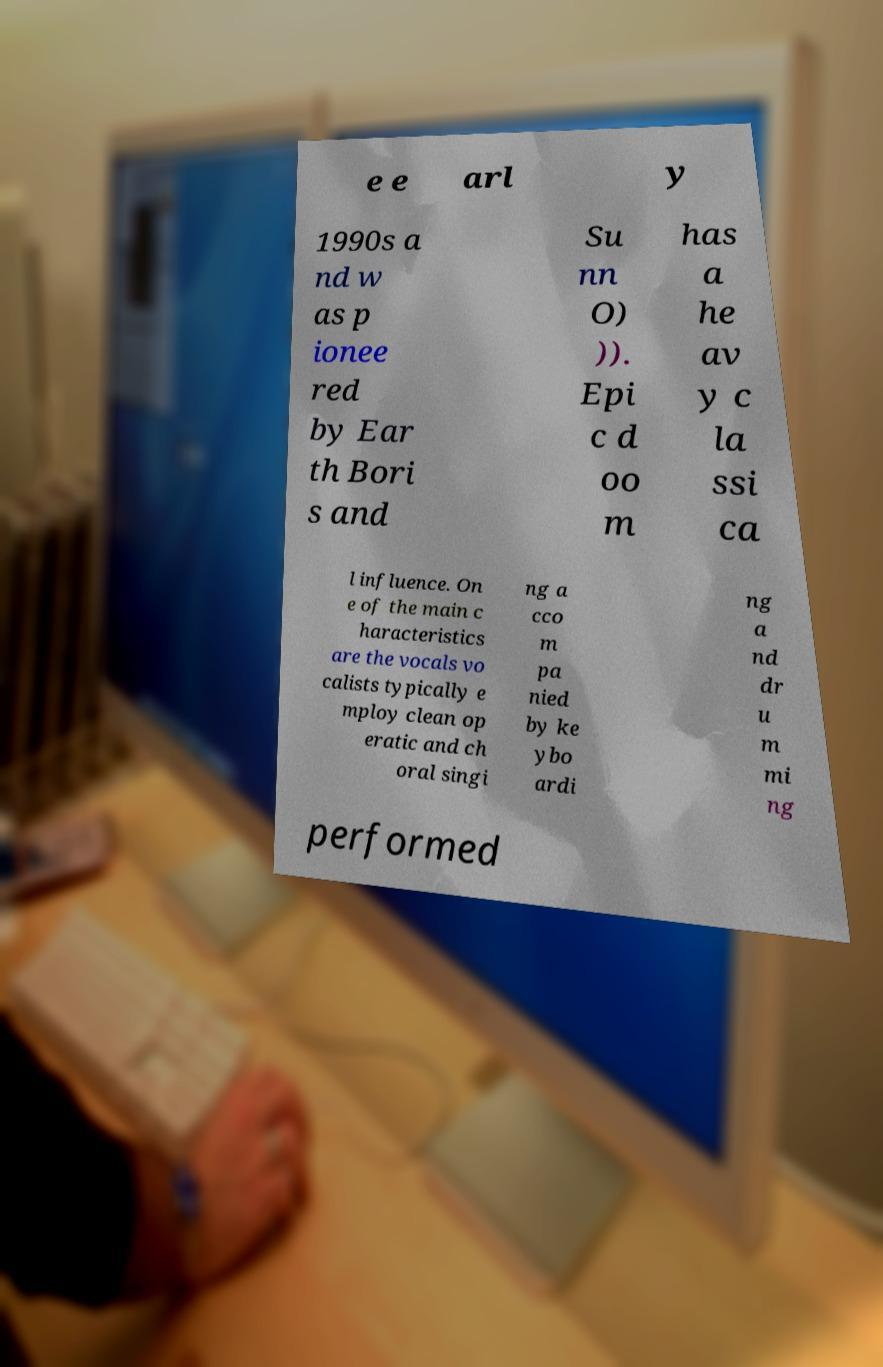For documentation purposes, I need the text within this image transcribed. Could you provide that? e e arl y 1990s a nd w as p ionee red by Ear th Bori s and Su nn O) )). Epi c d oo m has a he av y c la ssi ca l influence. On e of the main c haracteristics are the vocals vo calists typically e mploy clean op eratic and ch oral singi ng a cco m pa nied by ke ybo ardi ng a nd dr u m mi ng performed 